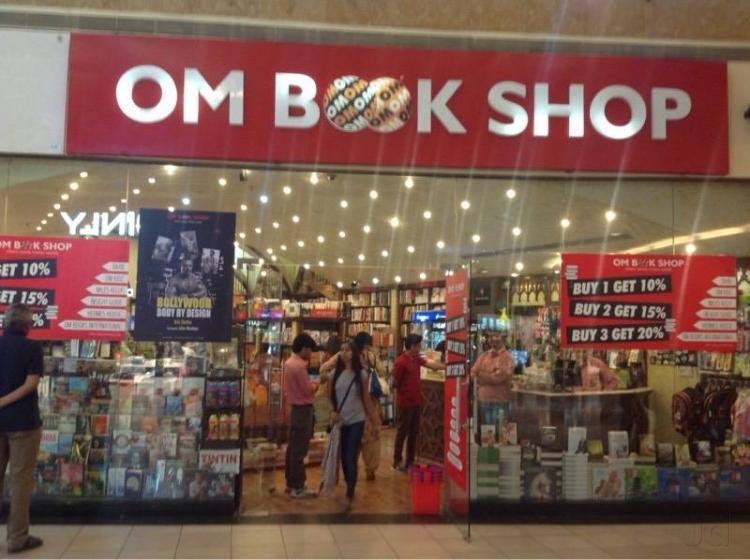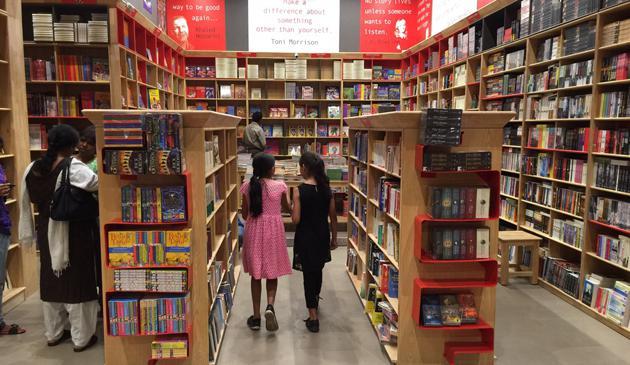The first image is the image on the left, the second image is the image on the right. For the images shown, is this caption "there are at least three people in the image on the right" true? Answer yes or no. Yes. 